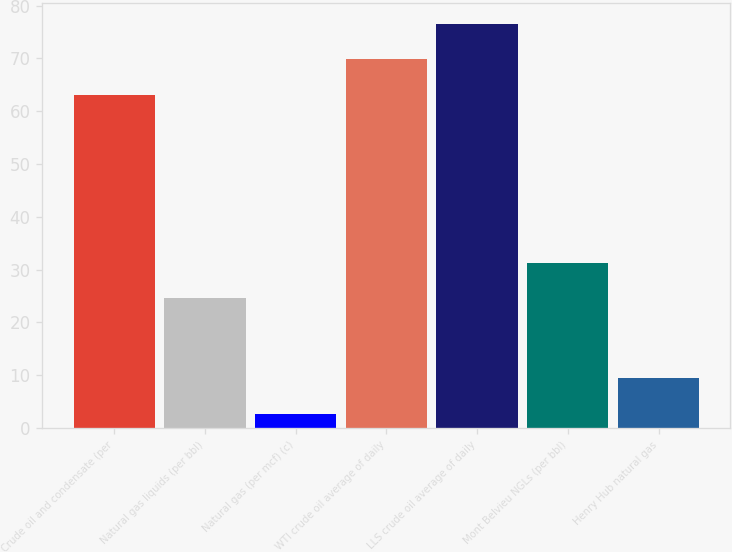Convert chart. <chart><loc_0><loc_0><loc_500><loc_500><bar_chart><fcel>Crude oil and condensate (per<fcel>Natural gas liquids (per bbl)<fcel>Natural gas (per mcf) (c)<fcel>WTI crude oil average of daily<fcel>LLS crude oil average of daily<fcel>Mont Belvieu NGLs (per bbl)<fcel>Henry Hub natural gas<nl><fcel>63.11<fcel>24.54<fcel>2.65<fcel>69.85<fcel>76.59<fcel>31.28<fcel>9.39<nl></chart> 